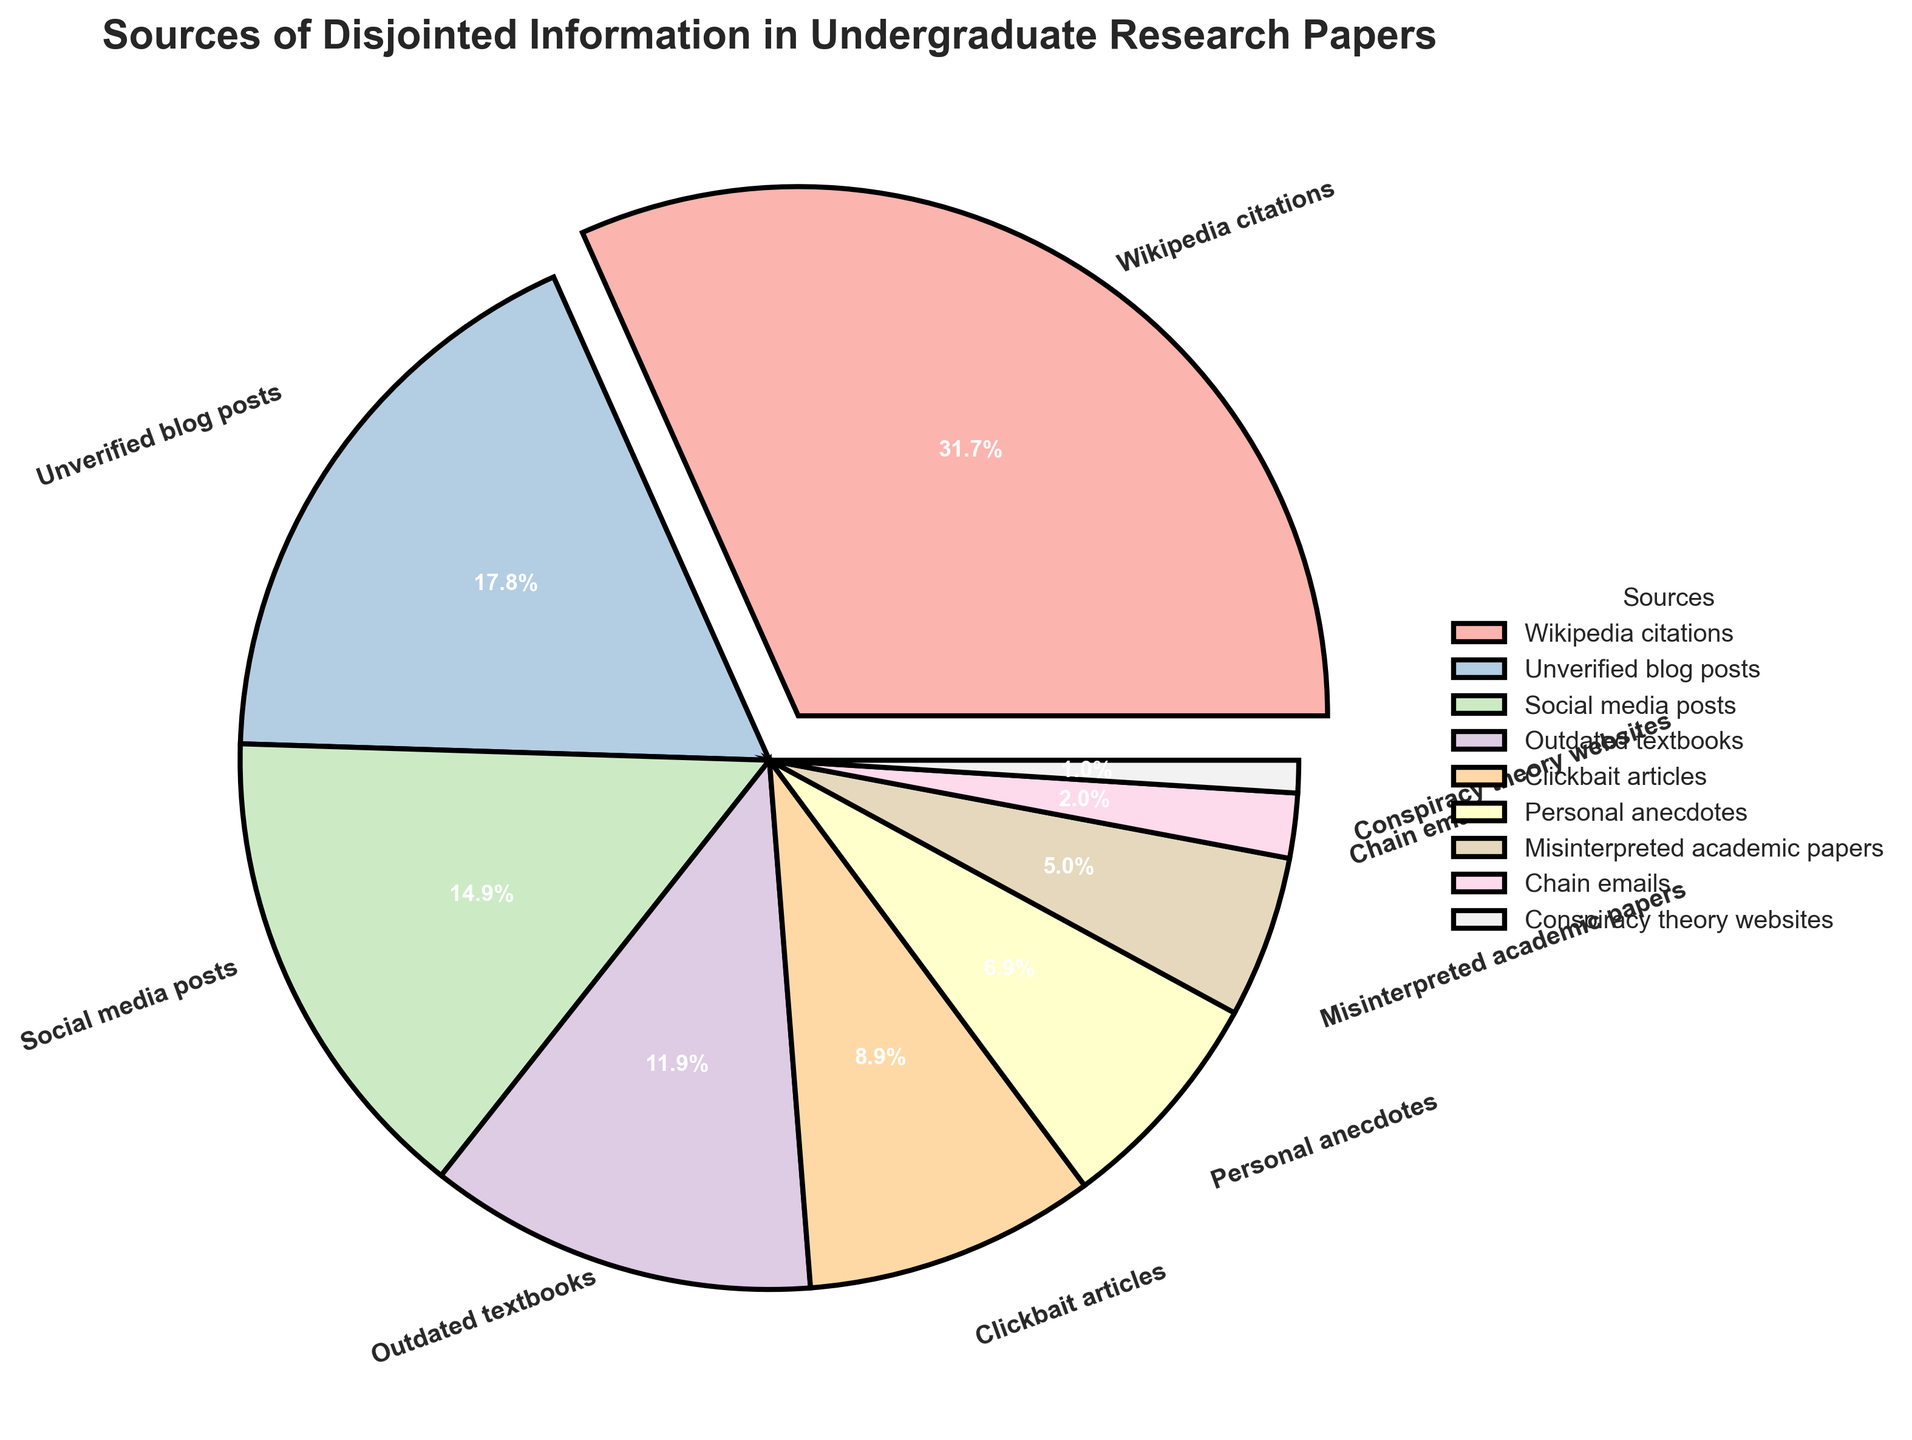Which source is the largest contributor to disjointed information in undergraduate research papers? In the pie chart, the section with the largest percentage is the one labeled "Wikipedia citations" with 32%.
Answer: Wikipedia citations Which sources together contribute to less than 10% of the disjointed information? From the pie chart, "Chain emails" (2%) and "Conspiracy theory websites" (1%) together contribute 2% + 1% = 3%, which is less than 10%.
Answer: Chain emails, Conspiracy theory websites What is the combined percentage of "Unverified blog posts" and "Outdated textbooks"? The pie chart shows "Unverified blog posts" contributing 18% and "Outdated textbooks" contributing 12%. Combined, they contribute 18% + 12% = 30%.
Answer: 30% Which category has a smaller percentage: "Social media posts" or "Clickbait articles"? "Social media posts" make up 15% of the pie, whereas "Clickbait articles" make up 9%. Therefore, "Clickbait articles" has a smaller percentage.
Answer: Clickbait articles What percentage of disjointed information comes from sources with less than or equal to 10% each? Adding "Clickbait articles" (9%), "Personal anecdotes" (7%), "Misinterpreted academic papers" (5%), "Chain emails" (2%), and "Conspiracy theory websites" (1%): 9% + 7% + 5% + 2% + 1% = 24%.
Answer: 24% Which category is represented by the wedge with the boldest color? The pie chart's boldest-colored wedge represents "Wikipedia citations" as it's the largest and closest to the axis.
Answer: Wikipedia citations How much more does "Wikipedia citations" contribute compared to "Conspiracy theory websites"? "Wikipedia citations" contributes 32% while "Conspiracy theory websites" contributes 1%. The difference is 32% - 1% = 31%.
Answer: 31% Which sources contribute an equal percentage of disjointed information? No two slices in the pie chart show the same percentage, so no two sources contribute equally.
Answer: None What percentage of disjointed information comes from "Social media posts" and "Personal anecdotes" combined? The pie chart indicates "Social media posts" at 15% and "Personal anecdotes" at 7%. Together, they contribute 15% + 7% = 22%.
Answer: 22% 